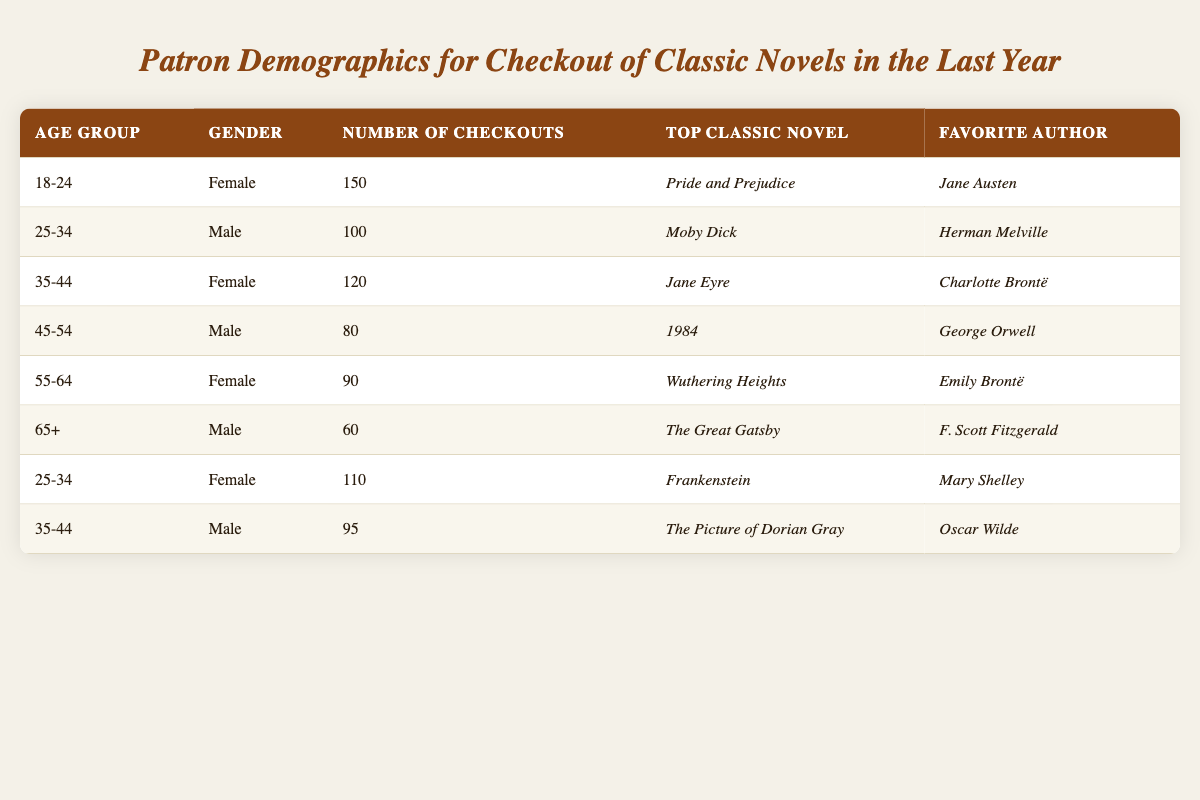What is the top classic novel checked out by patrons aged 18-24? The data shows that the number of checkouts for patrons aged 18-24 is 150, and their top classic novel is *Pride and Prejudice*.
Answer: *Pride and Prejudice* How many male patrons between the ages of 25-34 checked out classic novels? There are two entries for patrons aged 25-34, one male with 100 checkouts and one female with 110 checkouts. Therefore, the number of male patrons that checked out classic novels is 100.
Answer: 100 What is the favorite author of female patrons aged 55-64? According to the table, the favorite author of female patrons aged 55-64 is *Emily Brontë*, who has 90 checkouts and their top classic novel is *Wuthering Heights*.
Answer: *Emily Brontë* Which age group has the highest number of checkouts? The age group with the highest number of checkouts is 18-24 with 150 checkouts, compared to others like 25-34 with 210 combined and 35-44 with 215 combined. However, comparing individually, 18-24 is the highest at 150.
Answer: 18-24 How many checkouts did female patrons have in the age groups 18-24 and 55-64 combined? Female patrons aged 18-24 checked out 150 novels, and those aged 55-64 checked out 90 novels, so we add these together: 150 + 90 = 240.
Answer: 240 Is it true that the top classic novel checked out by patrons aged 65+ is *The Great Gatsby*? Yes, based on the table, the top classic novel for patrons aged 65 and above is indeed *The Great Gatsby*.
Answer: Yes What is the average number of checkouts for male patrons across all age groups listed? The total number of checkouts for male patrons is 100 (25-34) + 80 (45-54) + 60 (65+) + 95 (35-44) = 335. There are four male entries, so the average is 335 / 4 = 83.75.
Answer: 83.75 Which female patrons checked out the least number of classic novels? The least number of checkouts by female patrons is from the age group 55-64 with 90 checkouts and the top classic novel being *Wuthering Heights*.
Answer: 55-64 